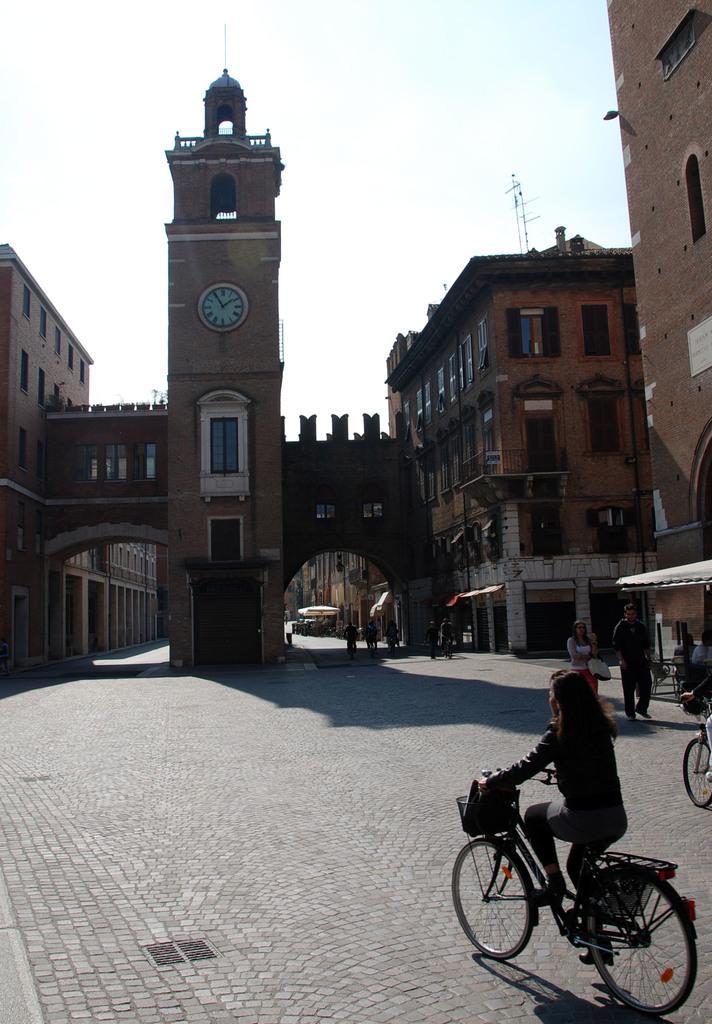In one or two sentences, can you explain what this image depicts? In the image there are two buildings attached with a clock tower in between and many people are moving around those buildings on that path, on the right side there is another building. 